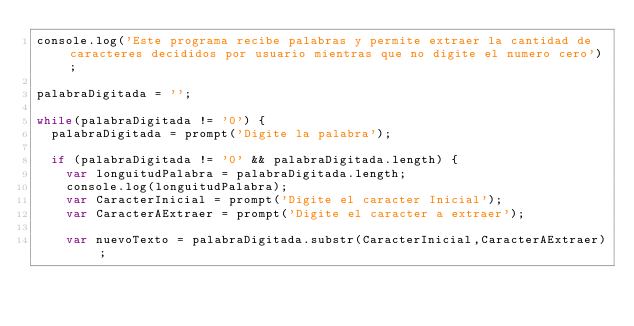<code> <loc_0><loc_0><loc_500><loc_500><_JavaScript_>console.log('Este programa recibe palabras y permite extraer la cantidad de caracteres decididos por usuario mientras que no digite el numero cero');

palabraDigitada = '';

while(palabraDigitada != '0') {
  palabraDigitada = prompt('Digite la palabra');

  if (palabraDigitada != '0' && palabraDigitada.length) {
    var longuitudPalabra = palabraDigitada.length;
    console.log(longuitudPalabra);
    var CaracterInicial = prompt('Digite el caracter Inicial');
    var CaracterAExtraer = prompt('Digite el caracter a extraer');

    var nuevoTexto = palabraDigitada.substr(CaracterInicial,CaracterAExtraer);</code> 